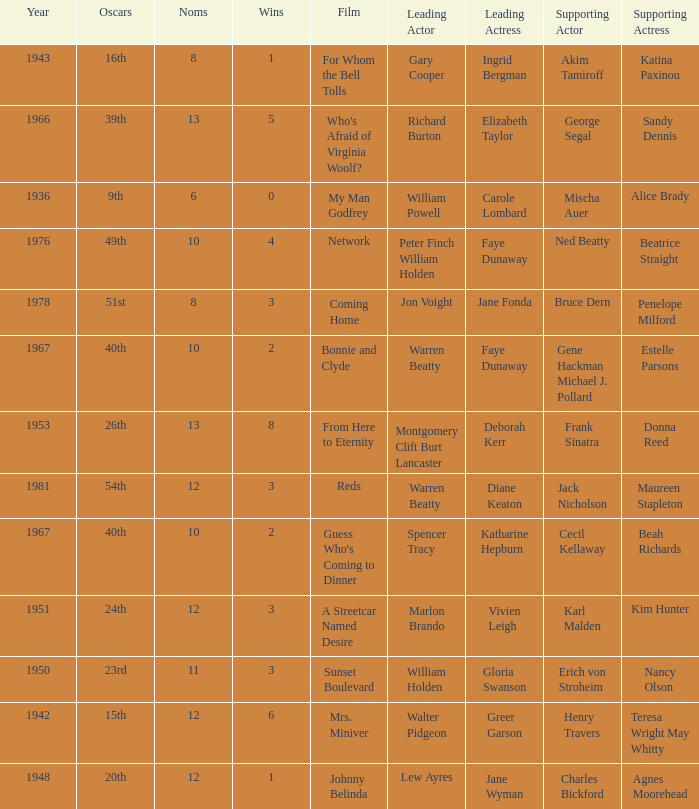Which film had Charles Bickford as supporting actor? Johnny Belinda. Could you parse the entire table? {'header': ['Year', 'Oscars', 'Noms', 'Wins', 'Film', 'Leading Actor', 'Leading Actress', 'Supporting Actor', 'Supporting Actress'], 'rows': [['1943', '16th', '8', '1', 'For Whom the Bell Tolls', 'Gary Cooper', 'Ingrid Bergman', 'Akim Tamiroff', 'Katina Paxinou'], ['1966', '39th', '13', '5', "Who's Afraid of Virginia Woolf?", 'Richard Burton', 'Elizabeth Taylor', 'George Segal', 'Sandy Dennis'], ['1936', '9th', '6', '0', 'My Man Godfrey', 'William Powell', 'Carole Lombard', 'Mischa Auer', 'Alice Brady'], ['1976', '49th', '10', '4', 'Network', 'Peter Finch William Holden', 'Faye Dunaway', 'Ned Beatty', 'Beatrice Straight'], ['1978', '51st', '8', '3', 'Coming Home', 'Jon Voight', 'Jane Fonda', 'Bruce Dern', 'Penelope Milford'], ['1967', '40th', '10', '2', 'Bonnie and Clyde', 'Warren Beatty', 'Faye Dunaway', 'Gene Hackman Michael J. Pollard', 'Estelle Parsons'], ['1953', '26th', '13', '8', 'From Here to Eternity', 'Montgomery Clift Burt Lancaster', 'Deborah Kerr', 'Frank Sinatra', 'Donna Reed'], ['1981', '54th', '12', '3', 'Reds', 'Warren Beatty', 'Diane Keaton', 'Jack Nicholson', 'Maureen Stapleton'], ['1967', '40th', '10', '2', "Guess Who's Coming to Dinner", 'Spencer Tracy', 'Katharine Hepburn', 'Cecil Kellaway', 'Beah Richards'], ['1951', '24th', '12', '3', 'A Streetcar Named Desire', 'Marlon Brando', 'Vivien Leigh', 'Karl Malden', 'Kim Hunter'], ['1950', '23rd', '11', '3', 'Sunset Boulevard', 'William Holden', 'Gloria Swanson', 'Erich von Stroheim', 'Nancy Olson'], ['1942', '15th', '12', '6', 'Mrs. Miniver', 'Walter Pidgeon', 'Greer Garson', 'Henry Travers', 'Teresa Wright May Whitty'], ['1948', '20th', '12', '1', 'Johnny Belinda', 'Lew Ayres', 'Jane Wyman', 'Charles Bickford', 'Agnes Moorehead']]} 